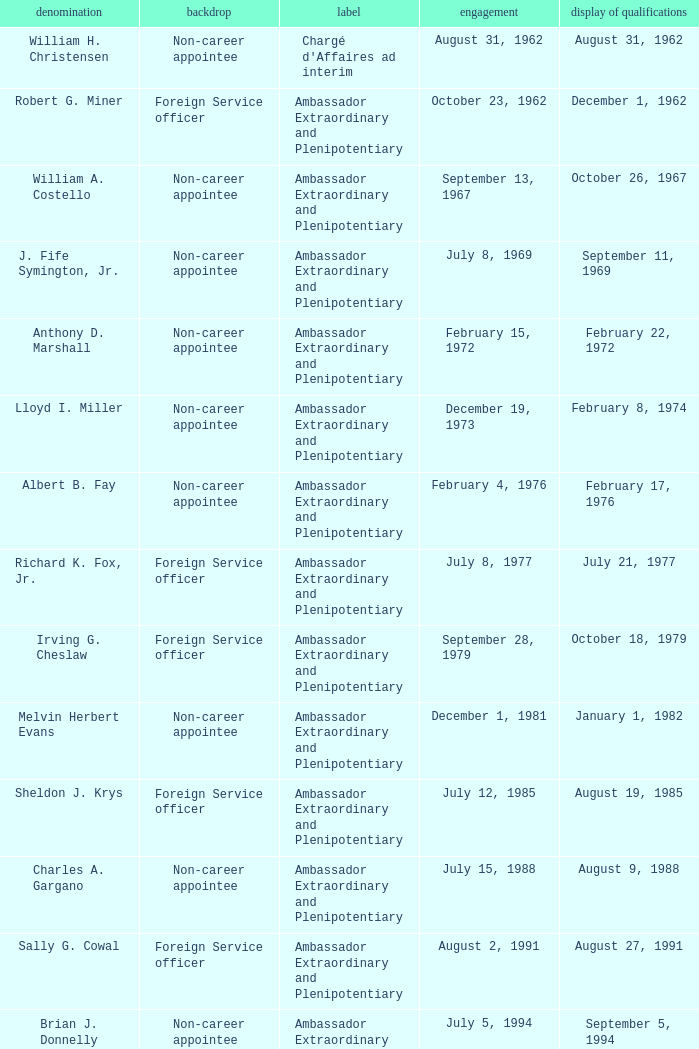When was William A. Costello appointed? September 13, 1967. 